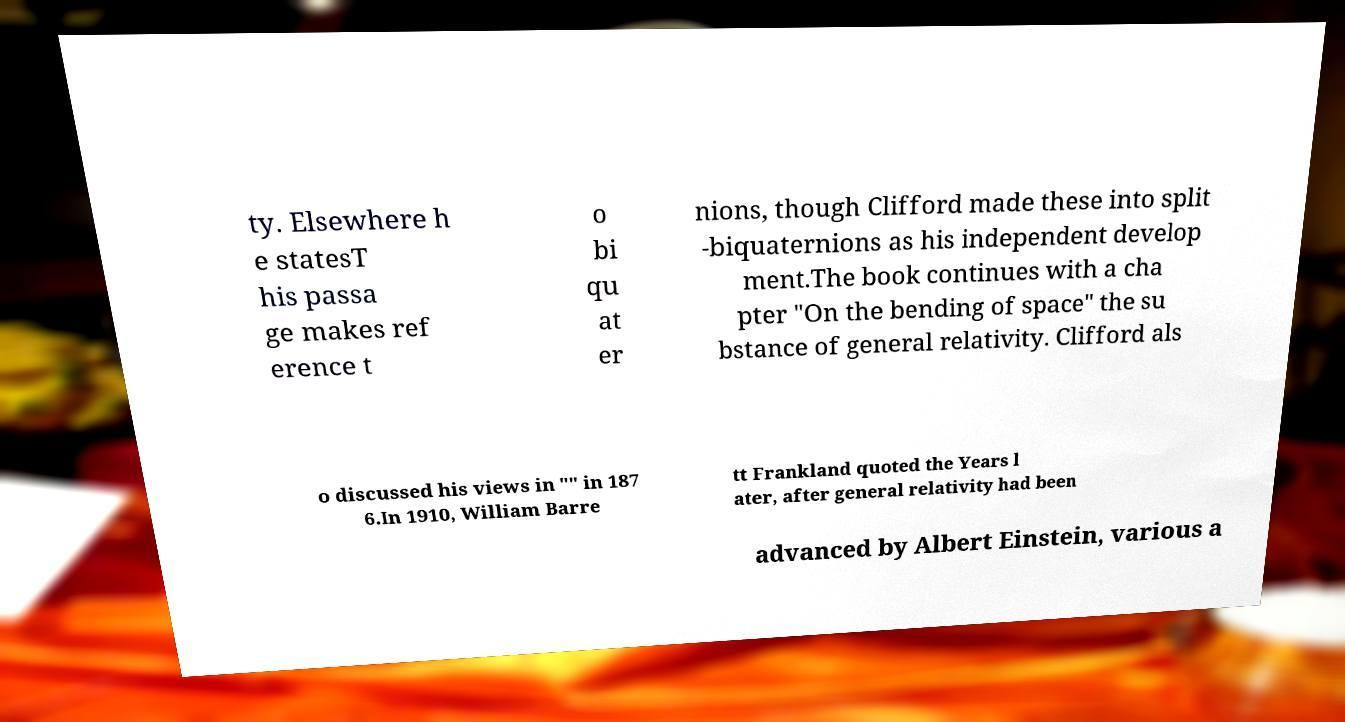I need the written content from this picture converted into text. Can you do that? ty. Elsewhere h e statesT his passa ge makes ref erence t o bi qu at er nions, though Clifford made these into split -biquaternions as his independent develop ment.The book continues with a cha pter "On the bending of space" the su bstance of general relativity. Clifford als o discussed his views in "" in 187 6.In 1910, William Barre tt Frankland quoted the Years l ater, after general relativity had been advanced by Albert Einstein, various a 